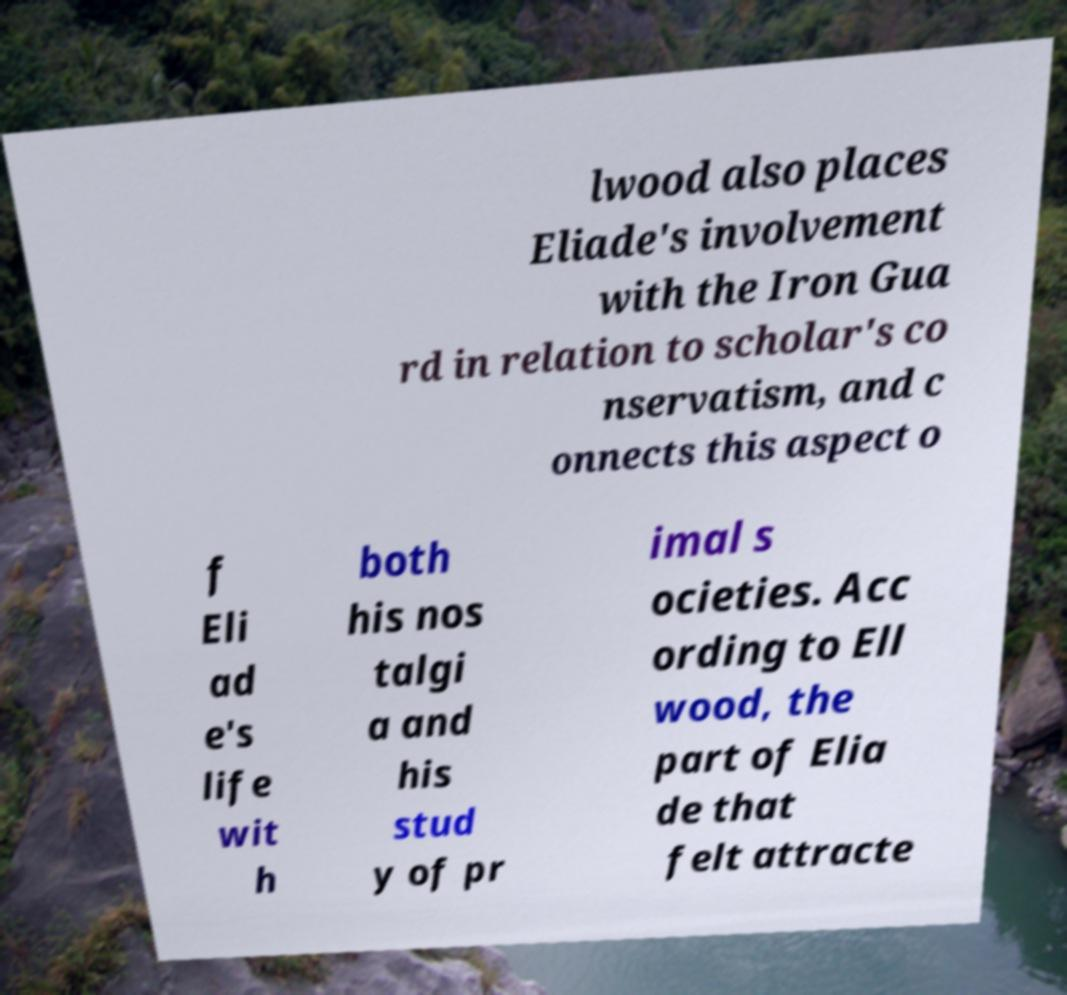Can you accurately transcribe the text from the provided image for me? lwood also places Eliade's involvement with the Iron Gua rd in relation to scholar's co nservatism, and c onnects this aspect o f Eli ad e's life wit h both his nos talgi a and his stud y of pr imal s ocieties. Acc ording to Ell wood, the part of Elia de that felt attracte 